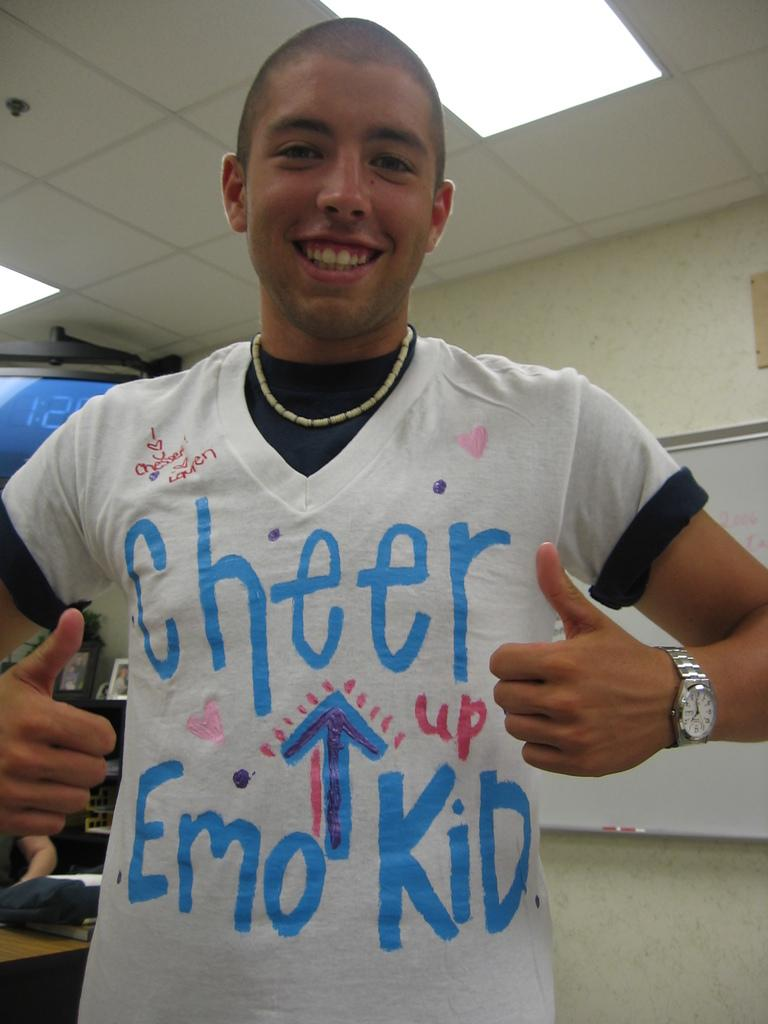<image>
Write a terse but informative summary of the picture. A young man wearing a tee shirt reading Cheer Emo Kid 